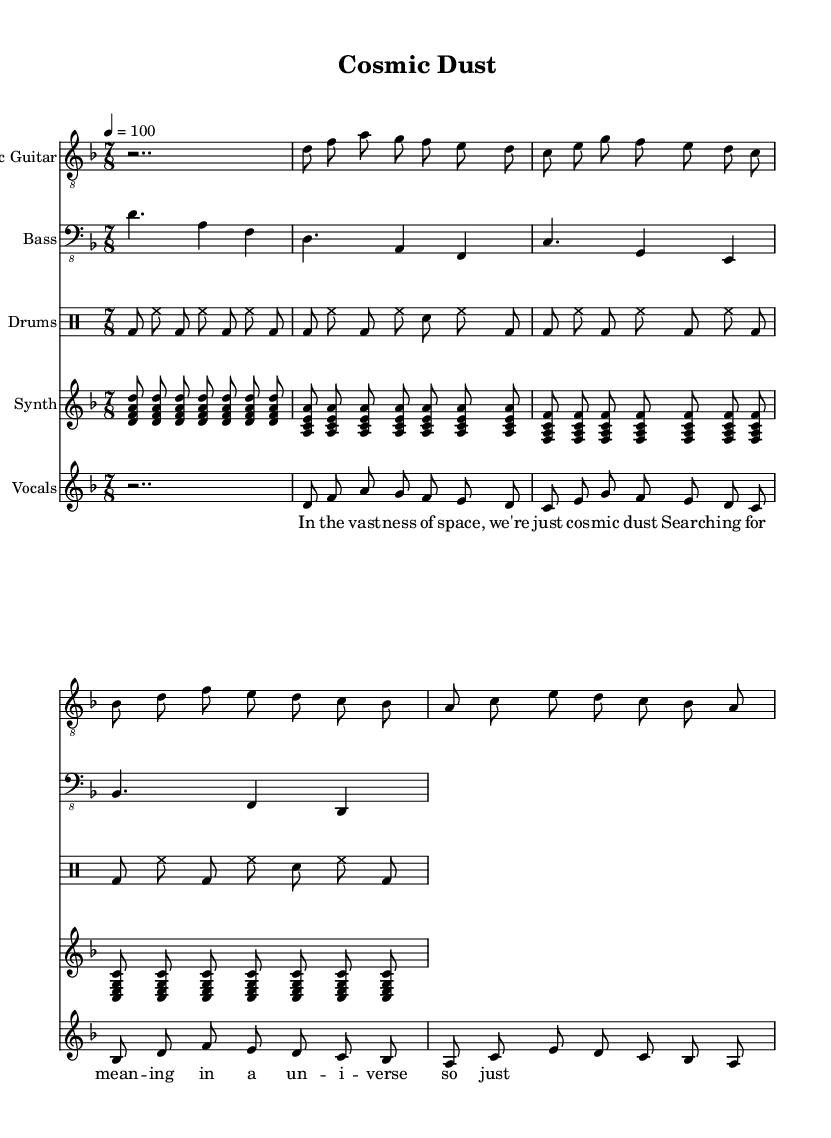What is the key signature of this music? The key signature is D minor, which contains one flat (B flat). It can be identified on the left side of the staff where the flat symbol is placed.
Answer: D minor What is the time signature of this music? The time signature is 7/8, which indicates there are seven beats in each measure, and the eighth note receives one beat. This is indicated at the beginning of the staff following the key signature.
Answer: 7/8 What is the tempo marking indicated for this piece? The tempo marking is 100, which is indicated as "4 = 100" above the staff. This means that the quarter note is to be played at a rate of 100 beats per minute.
Answer: 100 How many instruments are featured in this piece? There are five distinct parts: Electric Guitar, Bass, Drums, Synth, and Vocals. The parts are labeled at the beginning of each staff, which indicates the number of instruments.
Answer: Five What is the first note played by the electric guitar? The first note played by the electric guitar is D. This is found at the beginning of the electric guitar part where the notes are listed sequentially.
Answer: D What lyrical theme is suggested by the first line of the verse? The first line, "In the vast -- ness of space, we're just cosmic dust," suggests a theme of existential inquiry about human existence in the universe. This is reflected in the philosophical nature of the lyrics.
Answer: Existential inquiry Which staff has a drum part? The DrumStaff clearly indicates the section dedicated to drums, as labeled in the score. This helps differentiate it from other instrumental parts.
Answer: DrumStaff 